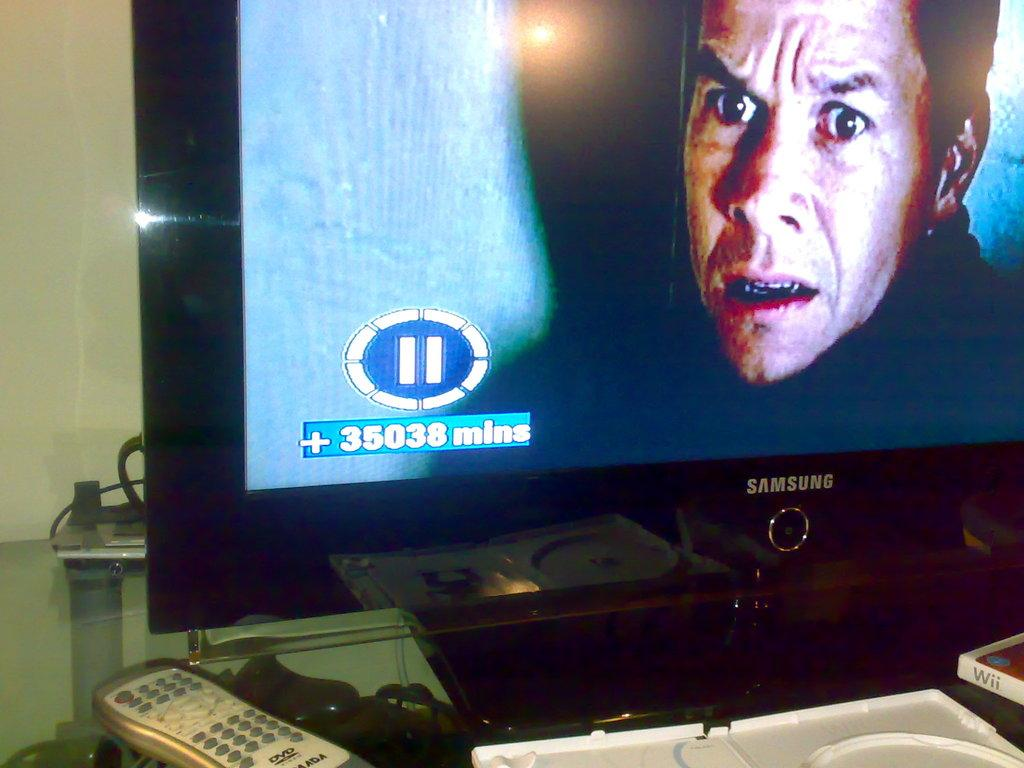<image>
Share a concise interpretation of the image provided. A black TV says Samsung and is showing a movie with Mark Wahlberg. 